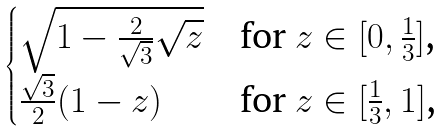<formula> <loc_0><loc_0><loc_500><loc_500>\begin{cases} \sqrt { 1 - \frac { 2 } { \sqrt { 3 } } \sqrt { z } } & \text {for $z\in[0,\frac{1}{3}]$,} \\ \frac { \sqrt { 3 } } { 2 } ( 1 - z ) & \text {for $z\in[\frac{1}{3},1]$,} \end{cases}</formula> 